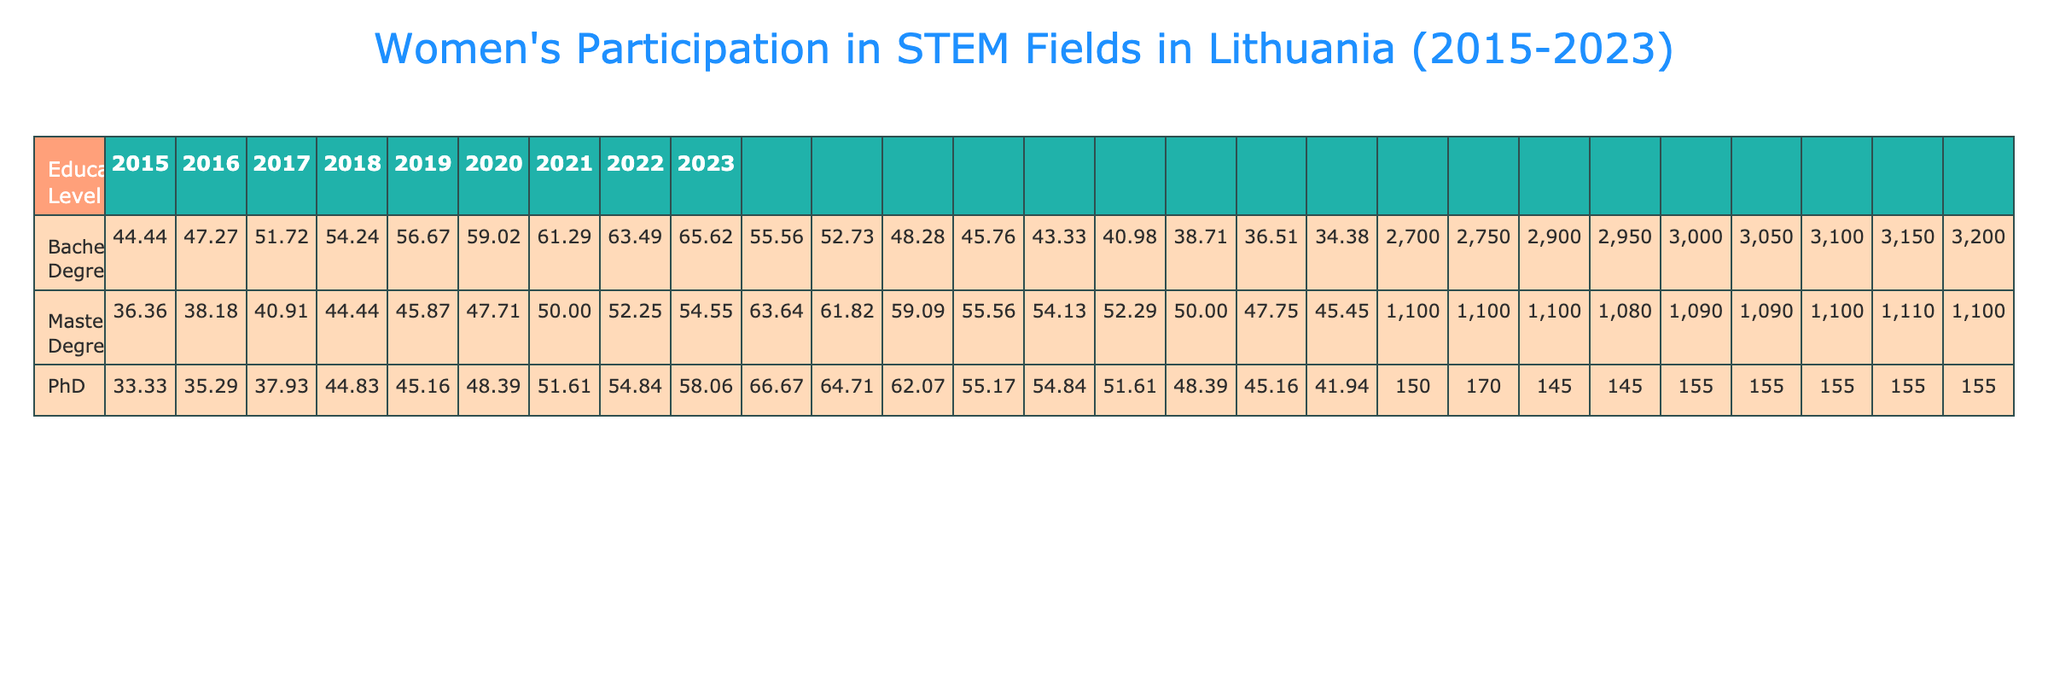What was the percentage of women enrolled in Master's Degree programs in 2020? The table shows that in 2020, the percentage of women enrolled in Master's Degree programs was 47.78%.
Answer: 47.78% Which educational level had the highest percentage of women in 2023? Looking at the 2023 data, the Bachelor's Degree level had the highest percentage of women enrolled at 65.25%.
Answer: Bachelor's Degree What was the total number of women enrolled in PhD programs throughout 2019 to 2023? By summing the total women enrolled in PhD from 2019 to 2023, we get 70 + 75 + 80 + 85 + 90 = 400.
Answer: 400 Did the percentage of women enrolled in Bachelor's Degree programs increase every year from 2015 to 2023? Yes, the percentage of women in Bachelor's Degree programs increased from 44.44% in 2015 to 65.25% in 2023, indicating a consistent increase each year.
Answer: Yes What is the average percentage of women enrolled in Master's Degree programs from 2015 to 2023? Calculating the average: (36.36 + 38.18 + 40.91 + 44.76 + 45.45 + 47.78 + 50 + 52.12 + 54.55) / 9 = 45.14%.
Answer: 45.14% In which year did the total enrollment for Bachelor's Degree programs reach 2100? According to the table, in the year 2023, the total enrollment for Bachelor's Degree programs reached 2100.
Answer: 2023 What was the percentage of men enrolled in PhD programs in 2021? In 2021, the percentage of men enrolled in PhD programs was 48.39%.
Answer: 48.39% How did the percentage of women in Master's Degree programs in 2018 compare to that in 2020? The percentage for 2018 was 44.76%, while for 2020 it was 47.78%, indicating an increase of 3.02% from 2018 to 2020.
Answer: Increased What is the total number of women enrolled in both Bachelor's and Master's Degree programs in 2022? Adding the total women enrolled in both degrees: 2000 (Bachelor's) + 580 (Master's) = 2580.
Answer: 2580 What was the percentage of men enrolled in Bachelor’s Degree programs in 2017? The percentage of men enrolled in Bachelor’s Degree programs in 2017 was 48.28%.
Answer: 48.28% Was there a decline in the percentage of women in any educational level from 2015 to 2023? No, for all three educational levels—Bachelor's, Master's, and PhD—the percentage of women did not decline over the years.
Answer: No 